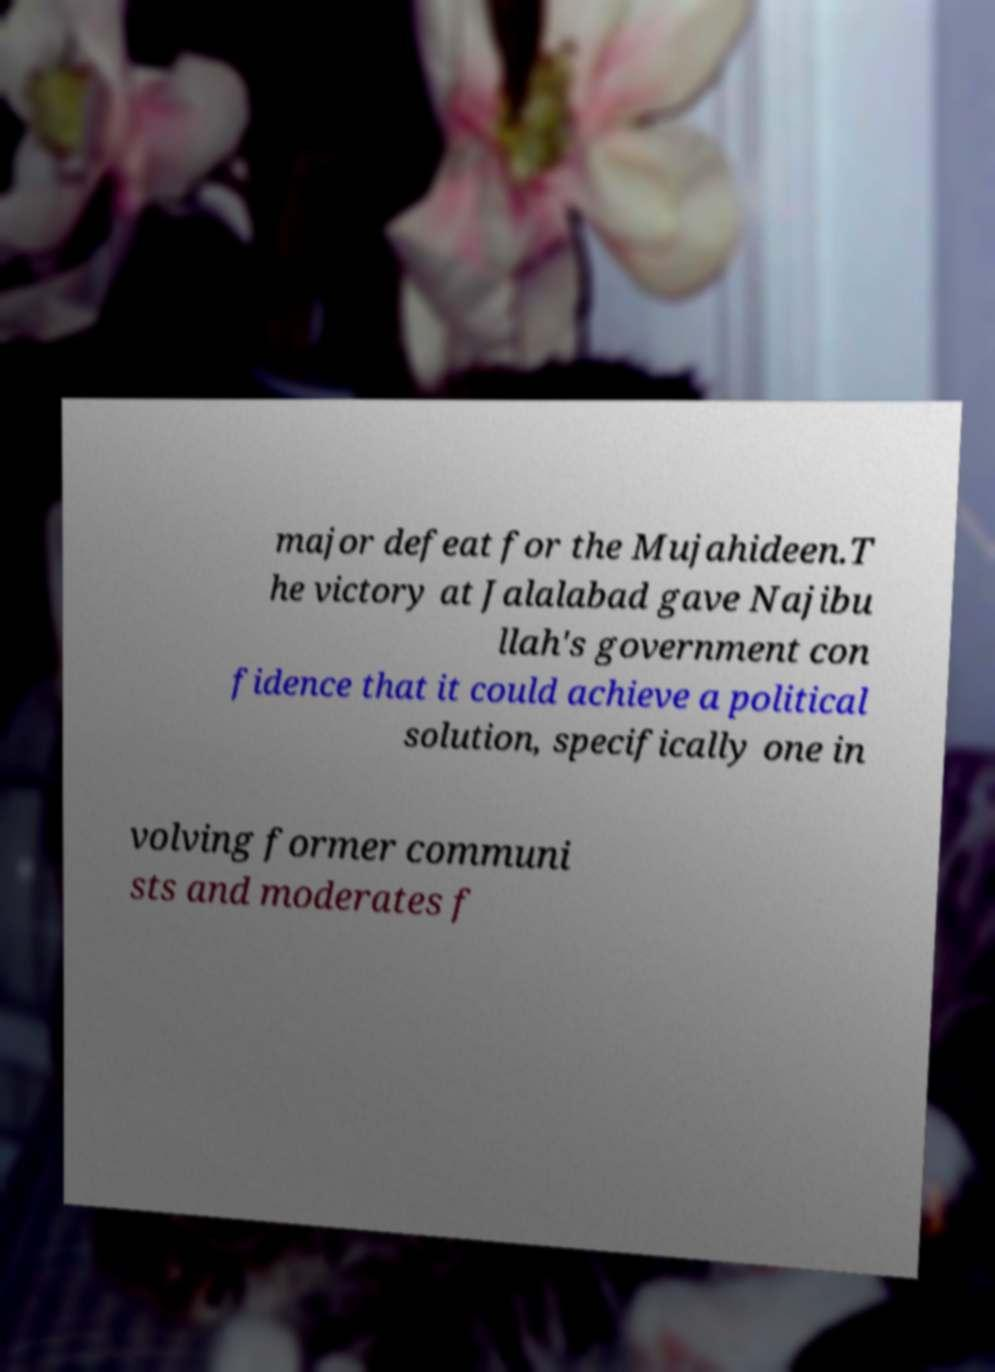Please identify and transcribe the text found in this image. major defeat for the Mujahideen.T he victory at Jalalabad gave Najibu llah's government con fidence that it could achieve a political solution, specifically one in volving former communi sts and moderates f 